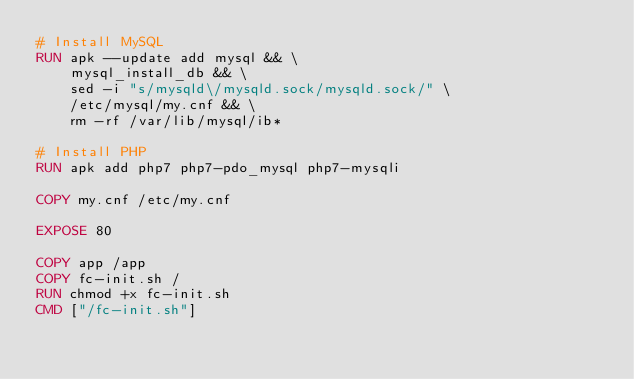Convert code to text. <code><loc_0><loc_0><loc_500><loc_500><_Dockerfile_># Install MySQL
RUN apk --update add mysql && \
    mysql_install_db && \
    sed -i "s/mysqld\/mysqld.sock/mysqld.sock/" \
    /etc/mysql/my.cnf && \
    rm -rf /var/lib/mysql/ib*

# Install PHP
RUN apk add php7 php7-pdo_mysql php7-mysqli

COPY my.cnf /etc/my.cnf

EXPOSE 80

COPY app /app
COPY fc-init.sh /
RUN chmod +x fc-init.sh
CMD ["/fc-init.sh"]
</code> 